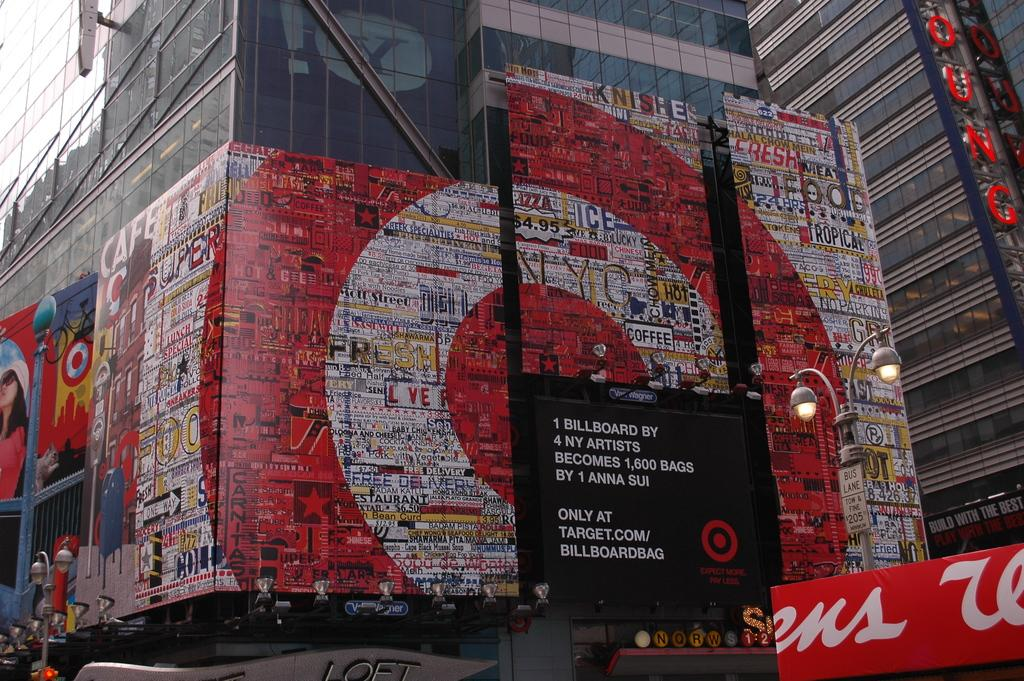<image>
Create a compact narrative representing the image presented. A Target billboard that was created by 4 artists from New York. 